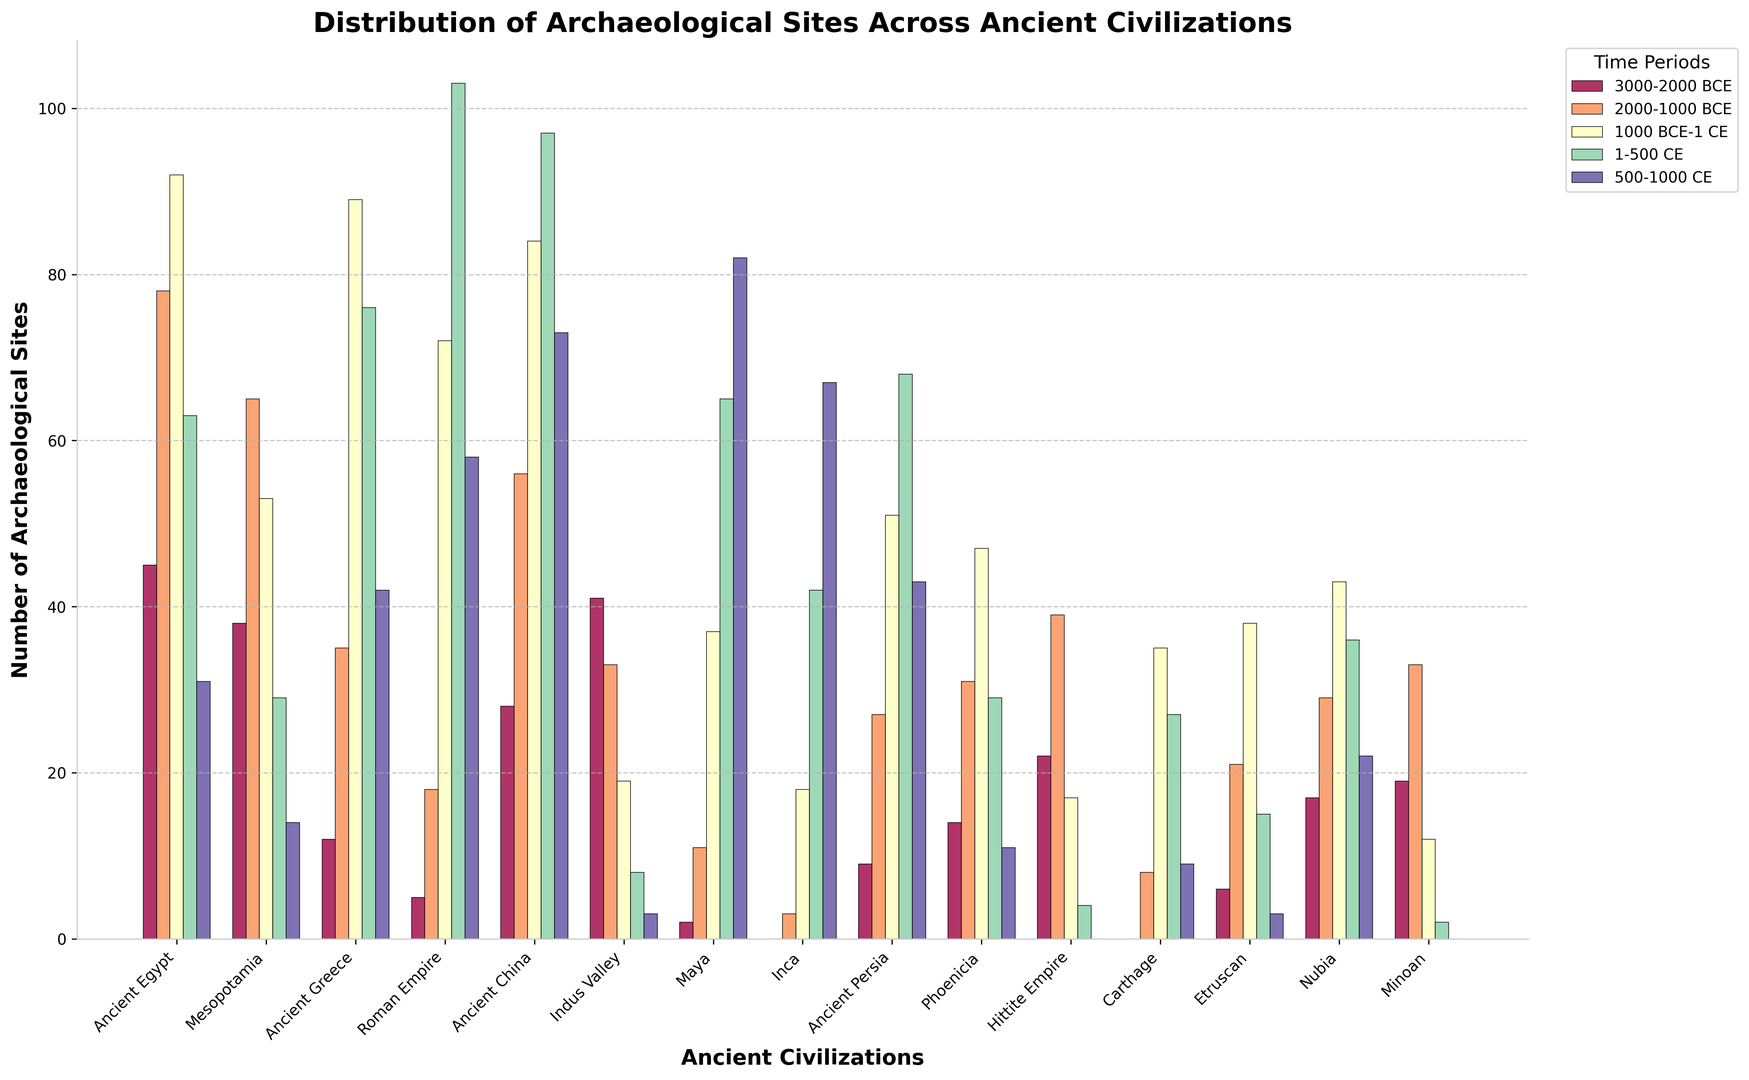What ancient civilization has the highest number of archaeological sites in the period between 1-500 CE? Look at the bar heights for the period "1-500 CE" across all civilizations. The tallest bar corresponds to the Roman Empire with 103 sites.
Answer: Roman Empire What is the total number of archaeological sites for Ancient Egypt across all time periods? Sum the number of sites for Ancient Egypt across all periods: 45 (3000-2000 BCE) + 78 (2000-1000 BCE) + 92 (1000 BCE-1 CE) + 63 (1-500 CE) + 31 (500-1000 CE) = 309.
Answer: 309 During which time period does the Maya civilization see the most significant increase in archaeological sites? Compare the bar heights for each time period for the Maya civilization. The largest increase occurs from "1-500 CE" to "500-1000 CE" (65 to 82, an increase of 17).
Answer: 500-1000 CE Which civilization has more archaeological sites in the period from 2000-1000 BCE, Ancient Greece or the Hittite Empire? Look at the bar heights for "2000-1000 BCE" for both civilizations. Ancient Greece has 35 sites, while the Hittite Empire has 39 sites.
Answer: Hittite Empire What is the average number of archaeological sites during 1000 BCE-1 CE across all civilizations? First, sum the number of sites for this period across all civilizations: 92 (AE) + 53 (M) + 89 (AG) + 72 (RE) + 84 (AC) + 19 (IV) + 37 (Maya) + 18 (Inca) + 51 (AP) + 47 (P) + 17 (HE) + 35 (C) + 38 (E) + 43 (N) + 12 (Minoan). The sum is 707. There are 15 civilizations, so the average is 707/15 ≈ 47.13.
Answer: 47.13 Between which consecutive periods did the number of archaeological sites for Ancient China increase the most? Look at the bars for Ancient China and compare the differences: 56-28 (28) between "3000-2000 BCE" and "2000-1000 BCE," 84-56 (28) between "2000-1000 BCE" and "1000 BCE-1 CE," 97-84 (13) between "1000 BCE-1 CE" and "1-500 CE," 73-97 (-24) between "1-500 CE" and "500-1000 CE." The largest increase is the tie between 3000-2000 BCE to 2000-1000 BCE and 2000-1000 BCE to 1000 BCE-1 CE.
Answer: 3000-2000 BCE to 2000-1000 BCE and 2000-1000 BCE to 1000 BCE-1 CE Which civilization had the fewest archaeological sites in the period from 3000-2000 BCE? Look at the bar heights for "3000-2000 BCE" for all civilizations. The Inca civilization has the lowest number, which is 0.
Answer: Inca How many more archaeological sites does the Roman Empire have in 1-500 CE compared to Ancient China in the same period? Subtract the number of sites for Ancient China (97) from the number of the Roman Empire (103) during 1-500 CE. The difference is 6.
Answer: 6 What is the ratio of the number of archaeological sites for Ancient Persia to the Indus Valley Civilization during 2000-1000 BCE? Divide the number of sites for Ancient Persia (27) by the number of Indus Valley Civilization (33) during 2000-1000 BCE. The ratio is 27/33 = 0.818.
Answer: 0.818 Comparing Phoenicia and Carthage, which civilization had a greater number of archaeological sites during "1-500 CE" and how many did it have more? Compare the bar heights for "1-500 CE" between Phoenicia (29) and Carthage (27). Phoenicia has 2 more sites than Carthage.
Answer: Phoenicia, 2 